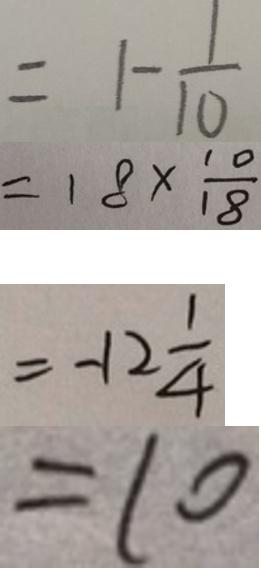Convert formula to latex. <formula><loc_0><loc_0><loc_500><loc_500>= 1 - \frac { 1 } { 1 0 } 
 = 1 8 \times \frac { 1 0 } { 1 8 } 
 = - 1 2 \frac { 1 } { 4 } 
 = 1 0</formula> 